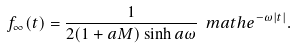Convert formula to latex. <formula><loc_0><loc_0><loc_500><loc_500>f _ { \infty } ( t ) = \frac { 1 } { 2 ( 1 + a M ) \sinh a \omega } \ m a t h e ^ { - \omega | t | } .</formula> 